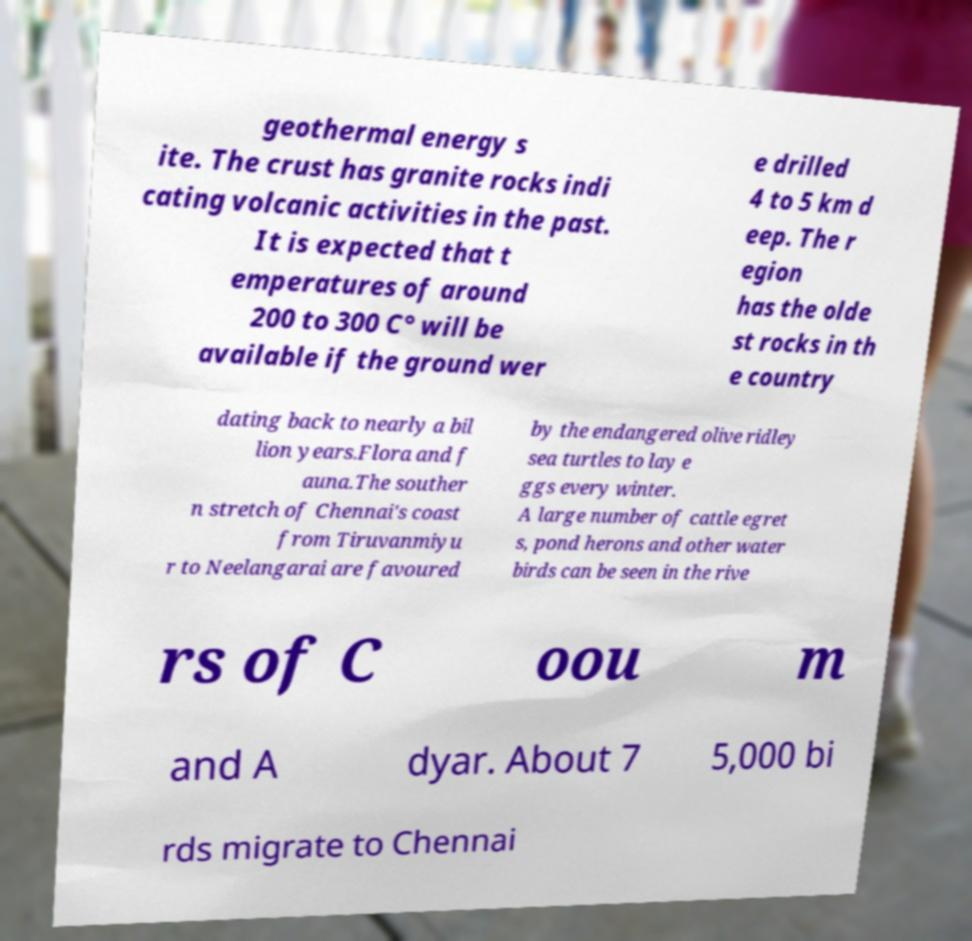For documentation purposes, I need the text within this image transcribed. Could you provide that? geothermal energy s ite. The crust has granite rocks indi cating volcanic activities in the past. It is expected that t emperatures of around 200 to 300 C° will be available if the ground wer e drilled 4 to 5 km d eep. The r egion has the olde st rocks in th e country dating back to nearly a bil lion years.Flora and f auna.The souther n stretch of Chennai's coast from Tiruvanmiyu r to Neelangarai are favoured by the endangered olive ridley sea turtles to lay e ggs every winter. A large number of cattle egret s, pond herons and other water birds can be seen in the rive rs of C oou m and A dyar. About 7 5,000 bi rds migrate to Chennai 